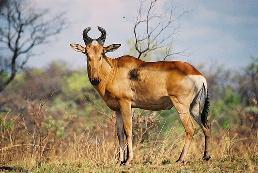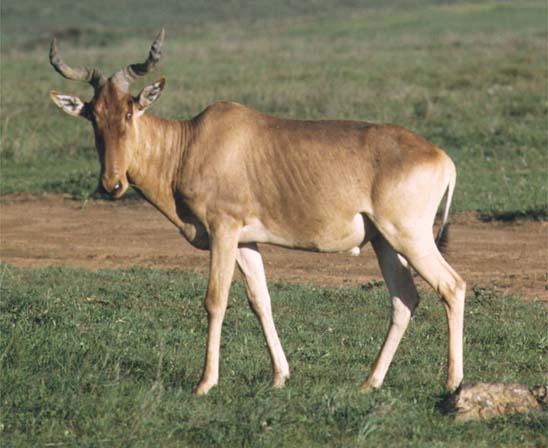The first image is the image on the left, the second image is the image on the right. Considering the images on both sides, is "There are two antelopes, both facing left." valid? Answer yes or no. Yes. The first image is the image on the left, the second image is the image on the right. Evaluate the accuracy of this statement regarding the images: "Each image contains a single horned animal in the foreground, and the animal's body is turned leftward.". Is it true? Answer yes or no. Yes. 